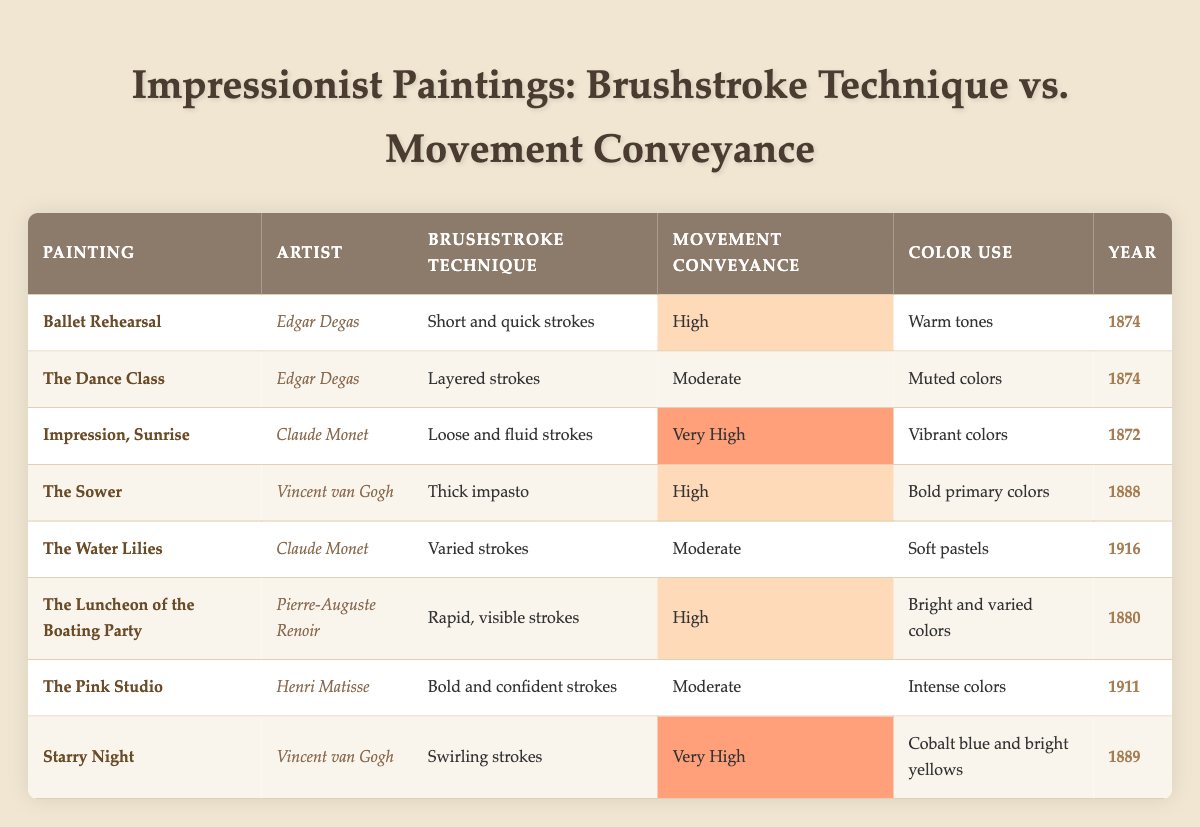What is the brushstroke technique used in "Starry Night"? Referring to the table, the brushstroke technique for "Starry Night" is listed as "Swirling strokes."
Answer: Swirling strokes Which painting by Edgar Degas has high movement conveyance? From the table, we see that both "Ballet Rehearsal" and "The Dance Class" are paintings by Edgar Degas. However, only "Ballet Rehearsal" is categorized as having "High" movement conveyance.
Answer: Ballet Rehearsal How many paintings have very high movement conveyance? The table indicates that there are two paintings with "Very High" movement conveyance: "Impression, Sunrise" and "Starry Night." Therefore, when counting these, the total is 2.
Answer: 2 What is the color use of "The Luncheon of the Boating Party"? Looking at the row for "The Luncheon of the Boating Party," the color use is specified as "Bright and varied colors."
Answer: Bright and varied colors Are any of the paintings completed in 1874 categorized as having moderate movement conveyance? Examining the table, the paintings completed in 1874 are "Ballet Rehearsal" and "The Dance Class." Only "The Dance Class" has "Moderate" movement conveyance, making the answer yes.
Answer: Yes What is the common brushstroke technique of the paintings completed between 1872 and 1889? The common brushstroke techniques from the table for paintings completed between 1872 and 1889 include "Loose and fluid strokes", "Thick impasto", and "Rapid, visible strokes". This shows diverse techniques used in this range.
Answer: Diverse techniques Calculate the average movement conveyance score from the data (assign values: Very High = 3, High = 2, Moderate = 1). First, assigning values: "Very High" as 3, "High" as 2, and "Moderate" as 1, we get scores of: "Ballet Rehearsal" (2), "The Dance Class" (1), "Impression, Sunrise" (3), "The Sower" (2), "The Water Lilies" (1), "The Luncheon of the Boating Party" (2), "The Pink Studio" (1), "Starry Night" (3). Summing these gives 16, dividing by 8 paintings gives an average of 2.
Answer: 2 Which artist has the highest percentage of high or very high movement conveyance paintings? We can see that Vincent van Gogh has two paintings: "The Sower" (High) and "Starry Night" (Very High). Thus, his percentage is (2/2) * 100% = 100%.
Answer: 100% List all unique brushstroke techniques used by Claude Monet. The table shows Claude Monet using "Loose and fluid strokes" and "Varied strokes." Thus, the unique brushstroke techniques present for Claude Monet are two.
Answer: Two 